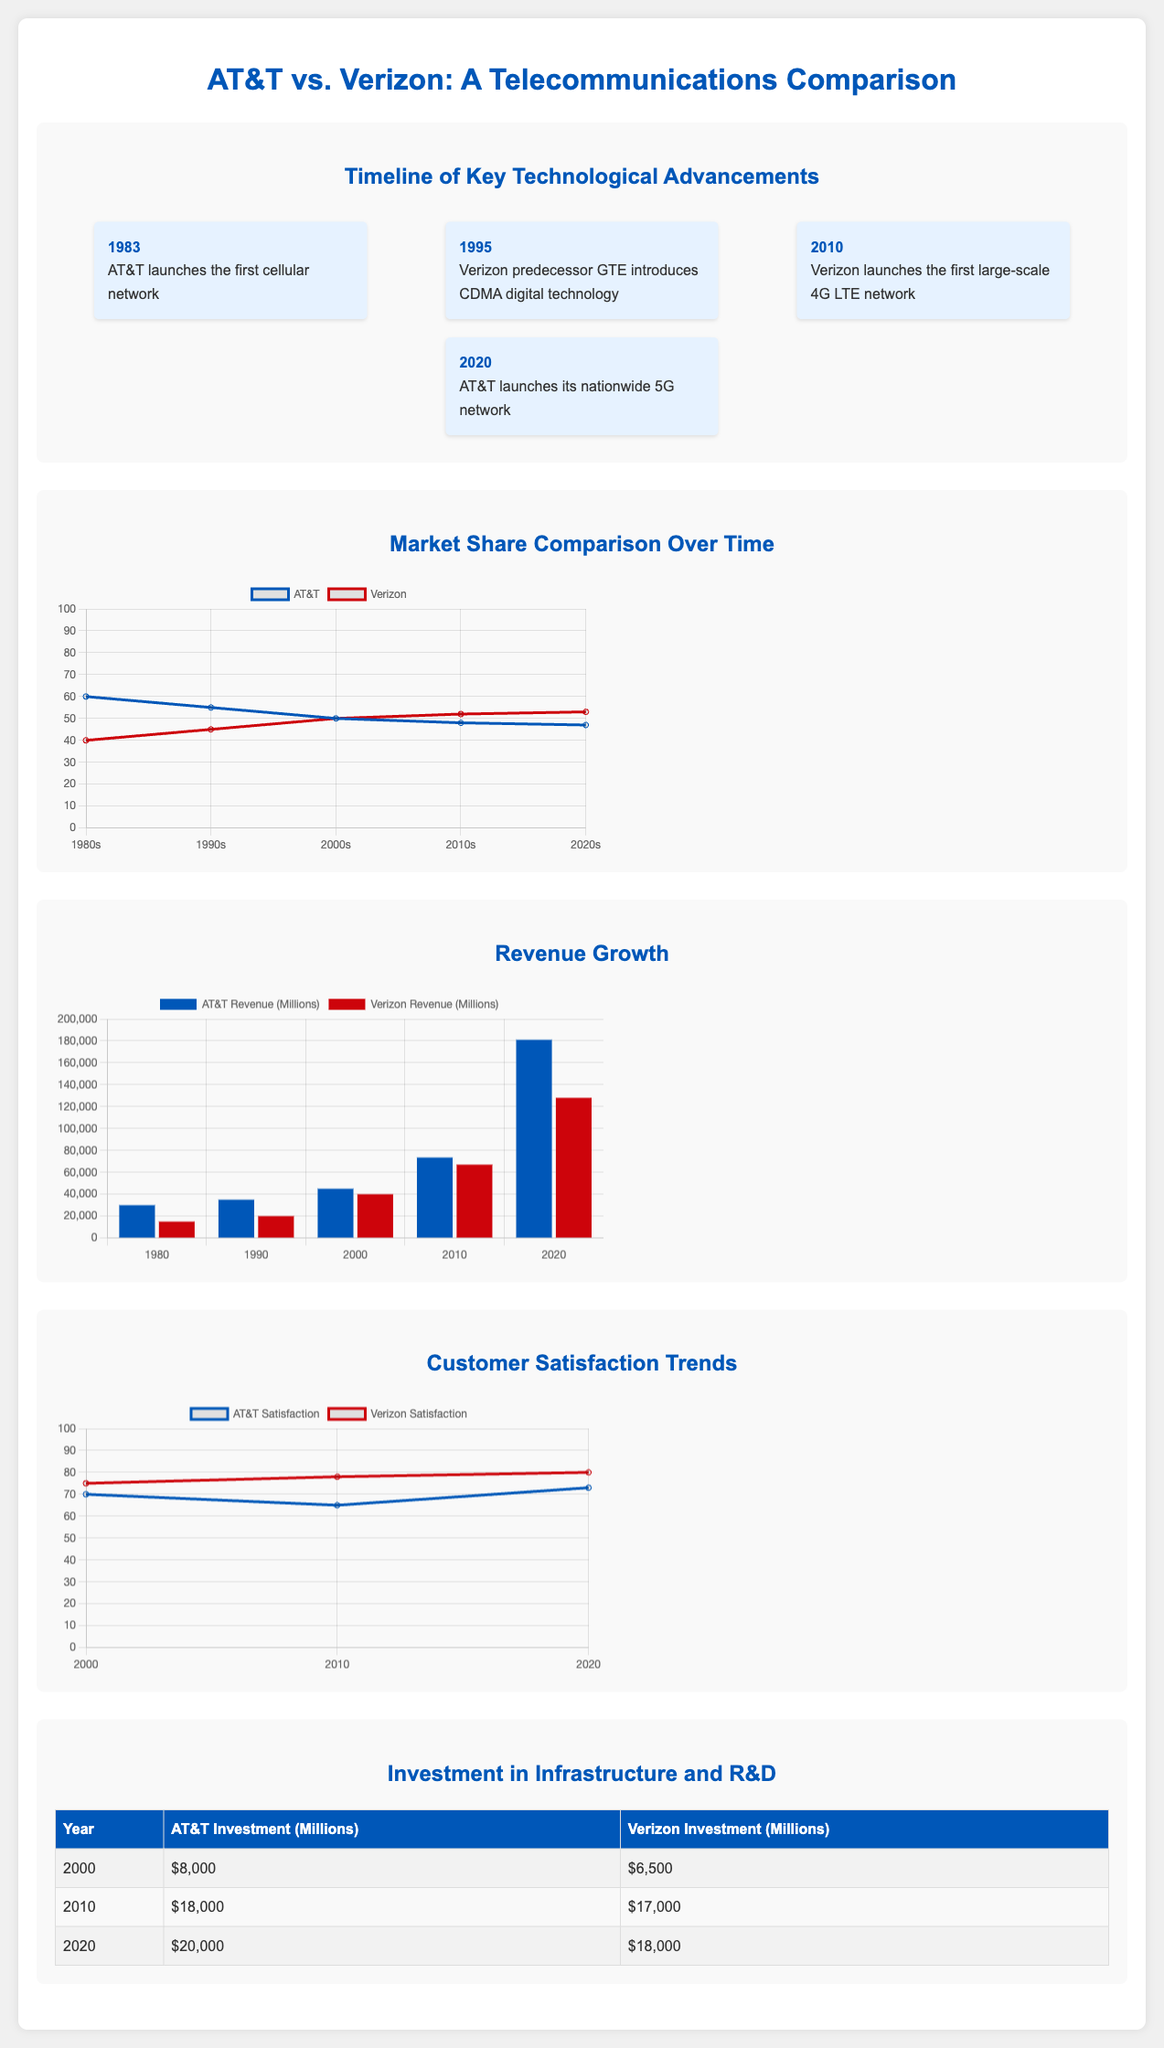What year did AT&T launch its first cellular network? The timeline mentions that AT&T launched its first cellular network in 1983.
Answer: 1983 What was Verizon's major technology introduction in 2010? The timeline states that Verizon launched the first large-scale 4G LTE network in 2010.
Answer: 4G LTE What is the market share percentage of AT&T in the 2020s? The line graph shows that AT&T's market share in the 2020s is 47%.
Answer: 47% What was the total investment by AT&T in 2010? The table indicates that AT&T's investment in 2010 was 18,000 million.
Answer: 18,000 million Which company had a higher customer satisfaction score in 2020? The satisfaction chart shows that Verizon had a score of 80, which is higher than AT&T's score of 73 in 2020.
Answer: Verizon How much revenue did AT&T generate in 2020? The revenue chart lists AT&T's revenue in 2020 as 181,000 million.
Answer: 181,000 million Which decade saw the introduction of CDMA technology by Verizon's predecessor? The timeline states that CDMA technology was introduced by Verizon's predecessor GTE in 1995.
Answer: 1995 What type of chart represents the investment in infrastructure and R&D? The document specifies that stacked bar charts are used to display investment in infrastructure and R&D.
Answer: Stacked bar charts What was the customer satisfaction rating for Verizon in 2010? The satisfaction chart indicates that Verizon's customer satisfaction rating in 2010 was 78.
Answer: 78 